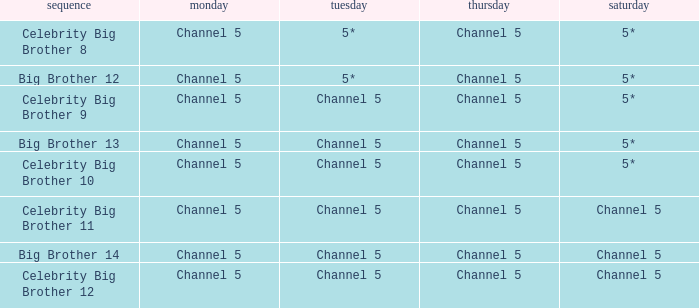Which Thursday does big brother 13 air? Channel 5. 